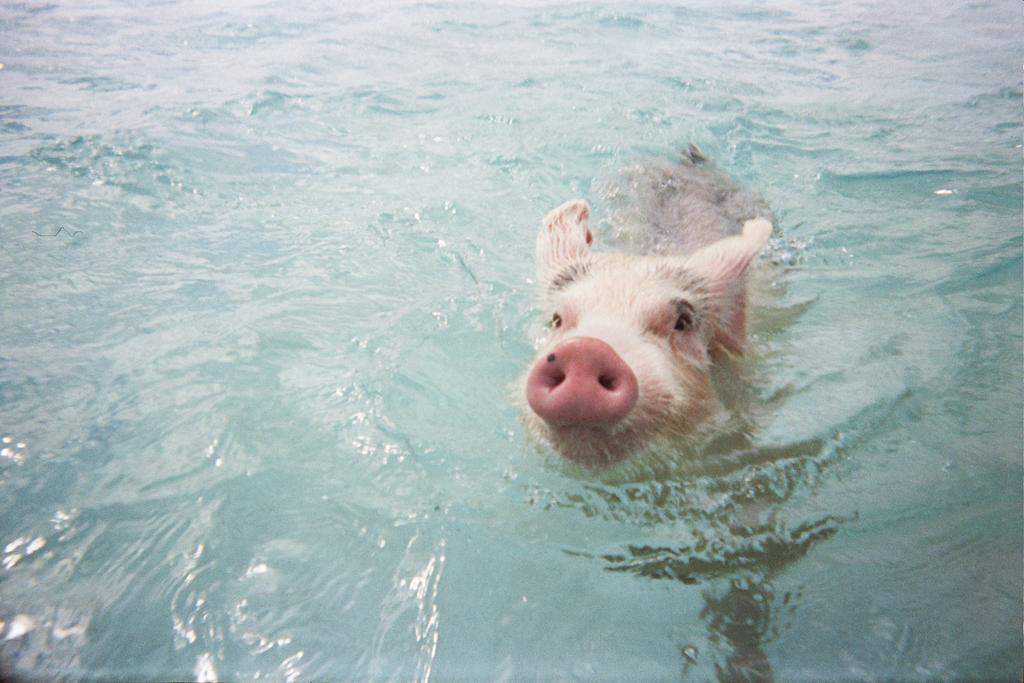What animal can be seen in the image? There is a pig in the image. What is the pig doing in the image? The pig is swimming in the water. What is the primary element in which the pig is situated? The pig is swimming in water, which is visible in the image. What is the pig's desire while swimming in the image? There is no information about the pig's desires in the image, as it only shows the pig swimming in water. 